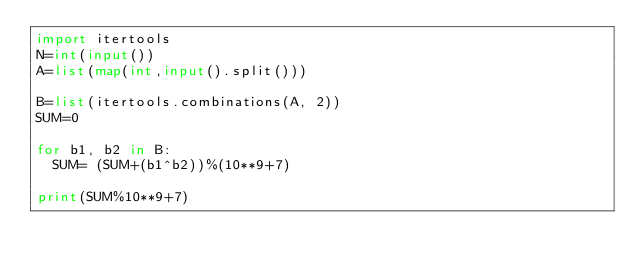Convert code to text. <code><loc_0><loc_0><loc_500><loc_500><_Python_>import itertools
N=int(input())
A=list(map(int,input().split()))

B=list(itertools.combinations(A, 2))
SUM=0

for b1, b2 in B:
  SUM= (SUM+(b1^b2))%(10**9+7)

print(SUM%10**9+7)</code> 